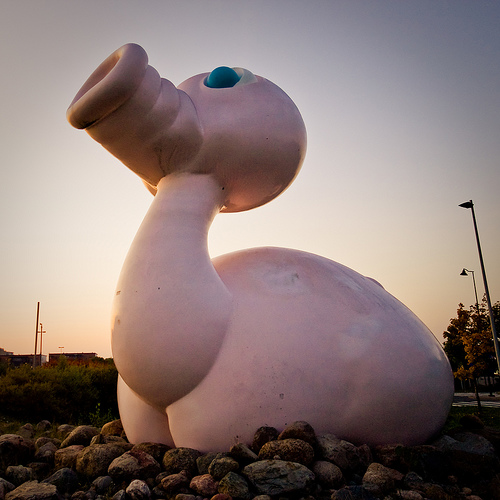<image>
Is there a statue in front of the light post? Yes. The statue is positioned in front of the light post, appearing closer to the camera viewpoint. 